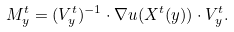Convert formula to latex. <formula><loc_0><loc_0><loc_500><loc_500>M ^ { t } _ { y } = ( V ^ { t } _ { y } ) ^ { - 1 } \cdot \nabla u ( X ^ { t } ( y ) ) \cdot V ^ { t } _ { y } .</formula> 